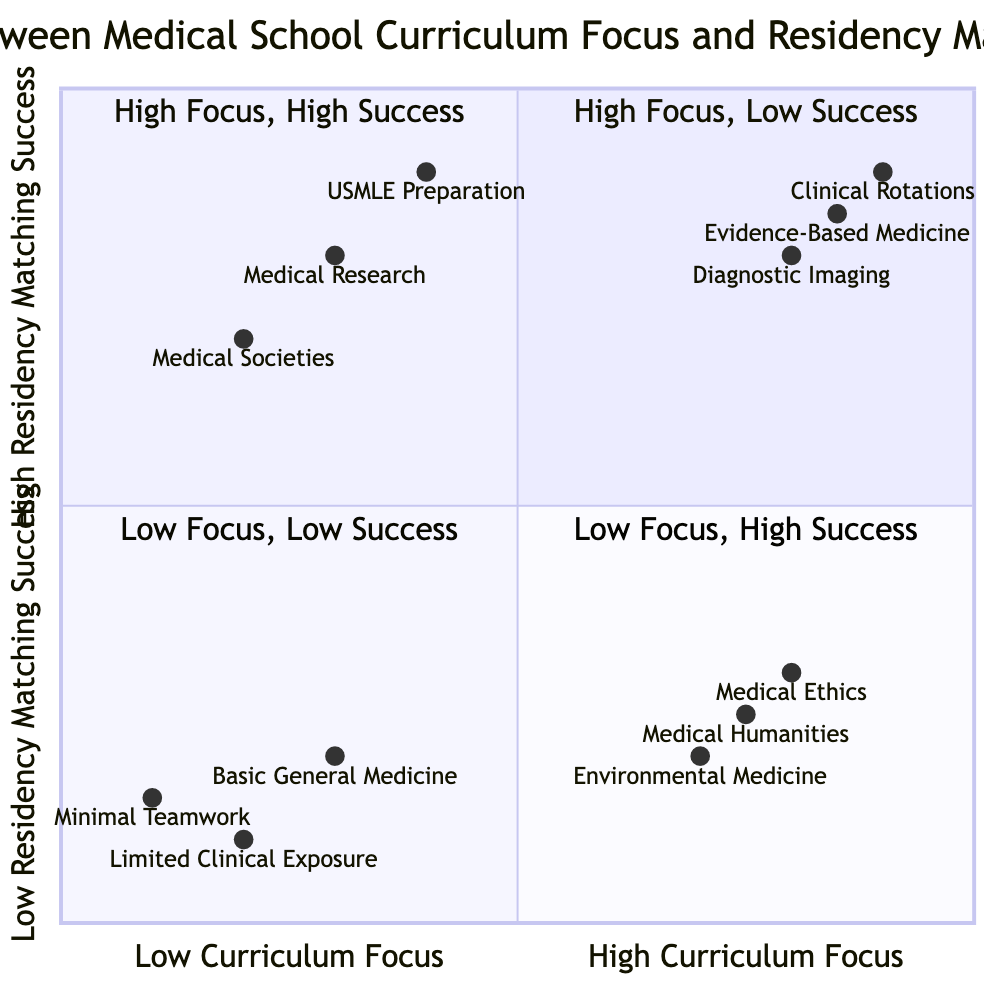What is the label of the Upper Right quadrant? The Upper Right quadrant presents strong outcomes, emphasizing that it has a high curriculum focus and high residency matching success, thus it carries the label "High Curriculum Focus, High Residency Matching Success."
Answer: High Curriculum Focus, High Residency Matching Success Which example from the Lower Left quadrant signifies minimal curriculum focus? In the Lower Left quadrant, each example points towards a lack of emphasis in the curriculum, among which "Limited Clinical Exposure" stands out as it indicates little engagement in practical clinical skills.
Answer: Limited Clinical Exposure How many examples are provided in the Upper Left quadrant? The Upper Left quadrant includes examples of medical curriculum focus that is high yet yields low residency matching success. Three examples are listed: Medical Ethics, Environmental Medicine, and Medical Humanities, totaling three.
Answer: 3 Which category has the highest residency matching success? In referencing the Upper Right quadrant, the examples show significant involvement in clinical training and strong results in matching, reflecting that "Comprehensive Curriculum in Evidence-Based Medicine" contributes to this outcome, affirming it as a critical category for matching success.
Answer: Comprehensive Curriculum in Evidence-Based Medicine In which quadrant do we see a strong emphasis on USMLE preparation? The strong emphasis on USMLE preparation is observed in the Lower Right quadrant, where despite a lower curriculum focus, the examples provided indicate that this preparation positively correlates with high residency matching success.
Answer: Lower Right Compare the success rates between "Limited Clinical Exposure" and "Strong Emphasis on USMLE Step 1 and Step 2 Preparation." "Limited Clinical Exposure" falls into the Lower Left quadrant with low success, registered at 0.1. Conversely, "Strong Emphasis on USMLE Step 1 and Step 2 Preparation," positioned in the Lower Right quadrant, demonstrates a much higher matching success rate at 0.9, indicating a notable difference in the outcomes between these examples.
Answer: Strong Emphasis on USMLE Step 1 and Step 2 Preparation Which quadrant has examples that show high residency matching success with low curriculum focus? The quadrant that contains instances of low curriculum focus yet achieves high residency matching success is the Lower Right quadrant, where examples such as "High Participation in Medical Research Opportunities" reflect this combination.
Answer: Lower Right What is the coordinate of "Advanced Training in Diagnostic Imaging Techniques"? The specific coordinate of "Advanced Training in Diagnostic Imaging Techniques" is [0.8, 0.8], placing it clearly within the boundaries of the Upper Right quadrant, indicating both a high curriculum focus and high residency matching success.
Answer: [0.8, 0.8] 